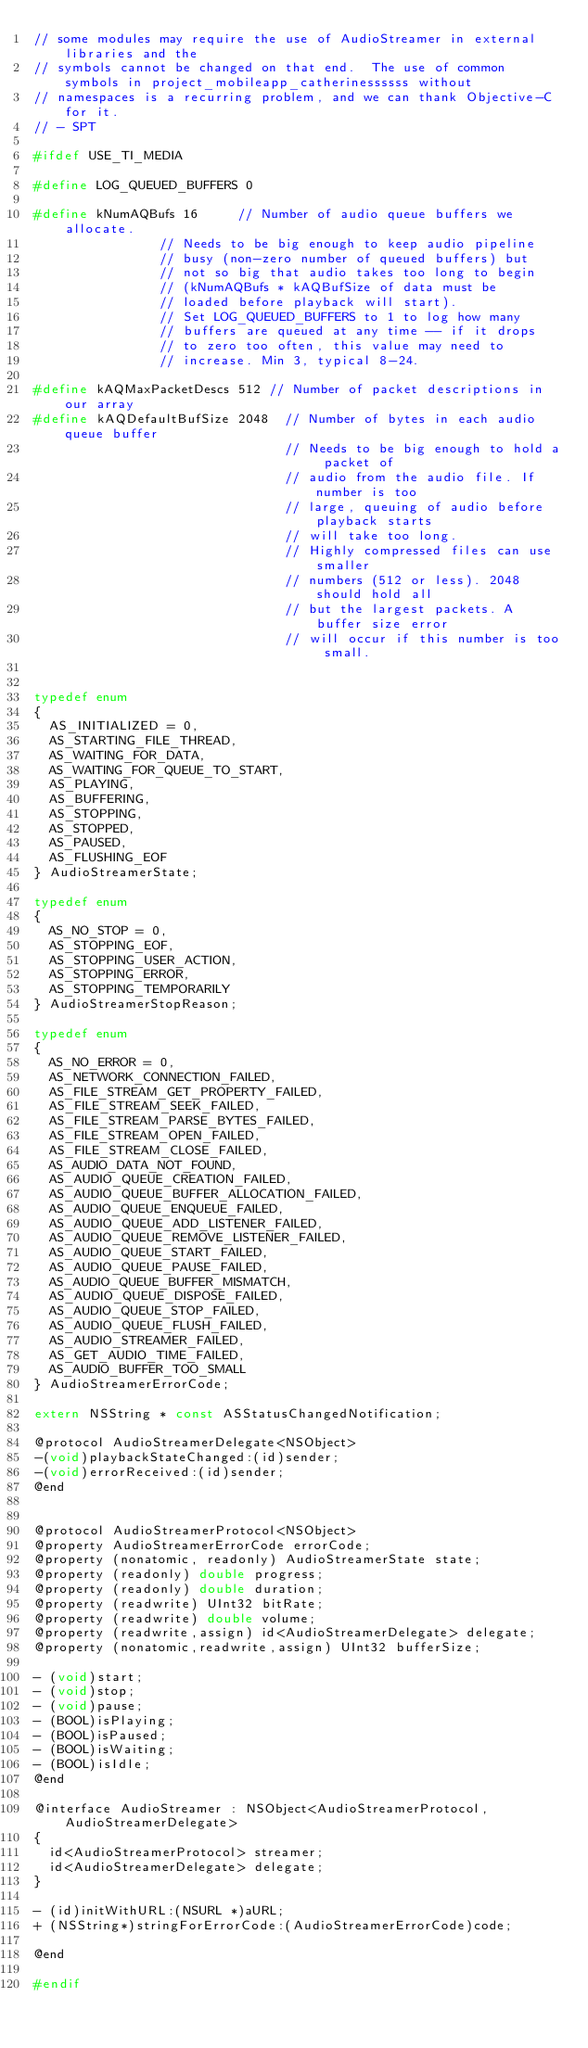<code> <loc_0><loc_0><loc_500><loc_500><_C_>// some modules may require the use of AudioStreamer in external libraries and the
// symbols cannot be changed on that end.  The use of common symbols in project_mobileapp_catherinessssss without
// namespaces is a recurring problem, and we can thank Objective-C for it.
// - SPT

#ifdef USE_TI_MEDIA

#define LOG_QUEUED_BUFFERS 0

#define kNumAQBufs 16			// Number of audio queue buffers we allocate.
								// Needs to be big enough to keep audio pipeline
								// busy (non-zero number of queued buffers) but
								// not so big that audio takes too long to begin
								// (kNumAQBufs * kAQBufSize of data must be
								// loaded before playback will start).
								// Set LOG_QUEUED_BUFFERS to 1 to log how many
								// buffers are queued at any time -- if it drops
								// to zero too often, this value may need to
								// increase. Min 3, typical 8-24.

#define kAQMaxPacketDescs 512	// Number of packet descriptions in our array
#define kAQDefaultBufSize 2048	// Number of bytes in each audio queue buffer
                                // Needs to be big enough to hold a packet of
                                // audio from the audio file. If number is too
                                // large, queuing of audio before playback starts
                                // will take too long.
                                // Highly compressed files can use smaller
                                // numbers (512 or less). 2048 should hold all
                                // but the largest packets. A buffer size error
                                // will occur if this number is too small.


typedef enum
{
	AS_INITIALIZED = 0,
	AS_STARTING_FILE_THREAD,
	AS_WAITING_FOR_DATA,
	AS_WAITING_FOR_QUEUE_TO_START,
	AS_PLAYING,
	AS_BUFFERING,
	AS_STOPPING,
	AS_STOPPED,
	AS_PAUSED,
	AS_FLUSHING_EOF
} AudioStreamerState;

typedef enum
{
	AS_NO_STOP = 0,
	AS_STOPPING_EOF,
	AS_STOPPING_USER_ACTION,
	AS_STOPPING_ERROR,
	AS_STOPPING_TEMPORARILY
} AudioStreamerStopReason;

typedef enum
{
	AS_NO_ERROR = 0,
	AS_NETWORK_CONNECTION_FAILED,
	AS_FILE_STREAM_GET_PROPERTY_FAILED,
	AS_FILE_STREAM_SEEK_FAILED,
	AS_FILE_STREAM_PARSE_BYTES_FAILED,
	AS_FILE_STREAM_OPEN_FAILED,
	AS_FILE_STREAM_CLOSE_FAILED,
	AS_AUDIO_DATA_NOT_FOUND,
	AS_AUDIO_QUEUE_CREATION_FAILED,
	AS_AUDIO_QUEUE_BUFFER_ALLOCATION_FAILED,
	AS_AUDIO_QUEUE_ENQUEUE_FAILED,
	AS_AUDIO_QUEUE_ADD_LISTENER_FAILED,
	AS_AUDIO_QUEUE_REMOVE_LISTENER_FAILED,
	AS_AUDIO_QUEUE_START_FAILED,
	AS_AUDIO_QUEUE_PAUSE_FAILED,
	AS_AUDIO_QUEUE_BUFFER_MISMATCH,
	AS_AUDIO_QUEUE_DISPOSE_FAILED,
	AS_AUDIO_QUEUE_STOP_FAILED,
	AS_AUDIO_QUEUE_FLUSH_FAILED,
	AS_AUDIO_STREAMER_FAILED,
	AS_GET_AUDIO_TIME_FAILED,
	AS_AUDIO_BUFFER_TOO_SMALL
} AudioStreamerErrorCode;

extern NSString * const ASStatusChangedNotification;

@protocol AudioStreamerDelegate<NSObject>
-(void)playbackStateChanged:(id)sender;
-(void)errorReceived:(id)sender;
@end


@protocol AudioStreamerProtocol<NSObject>
@property AudioStreamerErrorCode errorCode;
@property (nonatomic, readonly) AudioStreamerState state;
@property (readonly) double progress;
@property (readonly) double duration; 
@property (readwrite) UInt32 bitRate;
@property (readwrite) double volume;
@property (readwrite,assign) id<AudioStreamerDelegate> delegate;
@property (nonatomic,readwrite,assign) UInt32 bufferSize;

- (void)start;
- (void)stop;
- (void)pause;
- (BOOL)isPlaying;
- (BOOL)isPaused;
- (BOOL)isWaiting;
- (BOOL)isIdle;
@end

@interface AudioStreamer : NSObject<AudioStreamerProtocol,AudioStreamerDelegate>
{
	id<AudioStreamerProtocol> streamer;
	id<AudioStreamerDelegate> delegate;
}

- (id)initWithURL:(NSURL *)aURL;
+ (NSString*)stringForErrorCode:(AudioStreamerErrorCode)code;

@end

#endif
</code> 